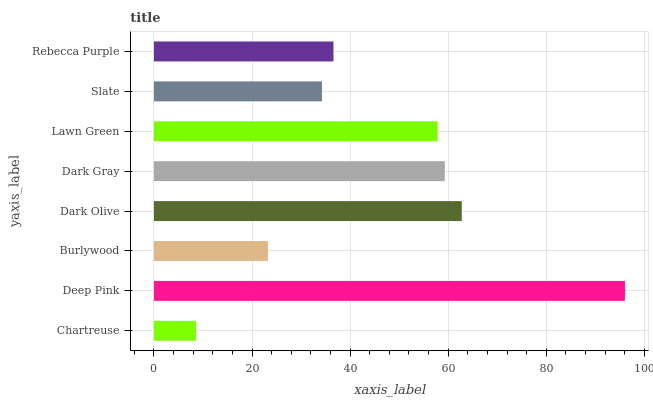Is Chartreuse the minimum?
Answer yes or no. Yes. Is Deep Pink the maximum?
Answer yes or no. Yes. Is Burlywood the minimum?
Answer yes or no. No. Is Burlywood the maximum?
Answer yes or no. No. Is Deep Pink greater than Burlywood?
Answer yes or no. Yes. Is Burlywood less than Deep Pink?
Answer yes or no. Yes. Is Burlywood greater than Deep Pink?
Answer yes or no. No. Is Deep Pink less than Burlywood?
Answer yes or no. No. Is Lawn Green the high median?
Answer yes or no. Yes. Is Rebecca Purple the low median?
Answer yes or no. Yes. Is Slate the high median?
Answer yes or no. No. Is Slate the low median?
Answer yes or no. No. 